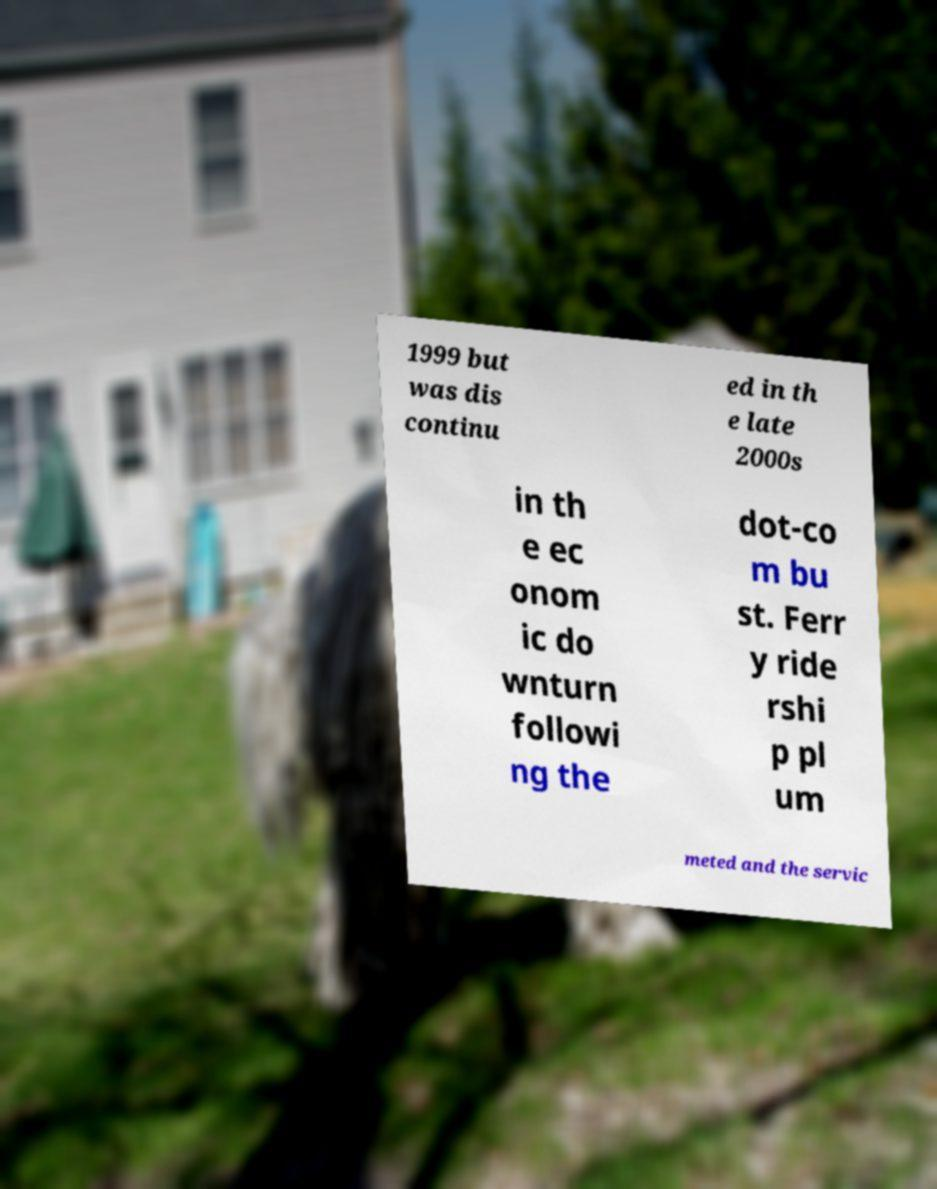What messages or text are displayed in this image? I need them in a readable, typed format. 1999 but was dis continu ed in th e late 2000s in th e ec onom ic do wnturn followi ng the dot-co m bu st. Ferr y ride rshi p pl um meted and the servic 